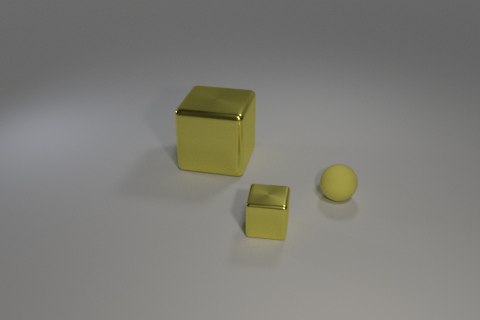There is another metal object that is the same color as the tiny metallic thing; what is its size?
Your response must be concise. Large. How many other things are there of the same size as the matte ball?
Make the answer very short. 1. Are there an equal number of small yellow blocks that are to the left of the big yellow object and large blue metal cylinders?
Ensure brevity in your answer.  Yes. There is a tiny thing that is to the right of the tiny block; is its color the same as the shiny object in front of the rubber sphere?
Give a very brief answer. Yes. What is the thing that is both in front of the large cube and behind the small shiny object made of?
Keep it short and to the point. Rubber. The large block has what color?
Your answer should be compact. Yellow. How many other things are the same shape as the yellow matte object?
Your response must be concise. 0. Are there the same number of big yellow metallic objects that are in front of the large object and large yellow metallic blocks left of the matte ball?
Your response must be concise. No. What material is the yellow ball?
Keep it short and to the point. Rubber. There is a cube that is behind the tiny yellow rubber ball; what material is it?
Offer a terse response. Metal. 